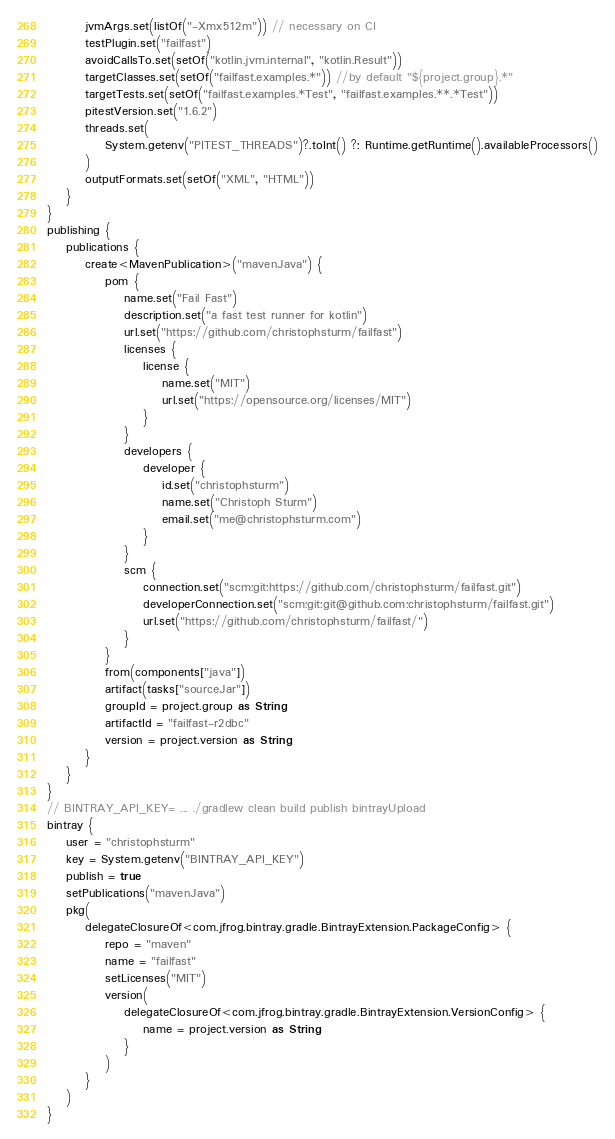<code> <loc_0><loc_0><loc_500><loc_500><_Kotlin_>        jvmArgs.set(listOf("-Xmx512m")) // necessary on CI
        testPlugin.set("failfast")
        avoidCallsTo.set(setOf("kotlin.jvm.internal", "kotlin.Result"))
        targetClasses.set(setOf("failfast.examples.*")) //by default "${project.group}.*"
        targetTests.set(setOf("failfast.examples.*Test", "failfast.examples.**.*Test"))
        pitestVersion.set("1.6.2")
        threads.set(
            System.getenv("PITEST_THREADS")?.toInt() ?: Runtime.getRuntime().availableProcessors()
        )
        outputFormats.set(setOf("XML", "HTML"))
    }
}
publishing {
    publications {
        create<MavenPublication>("mavenJava") {
            pom {
                name.set("Fail Fast")
                description.set("a fast test runner for kotlin")
                url.set("https://github.com/christophsturm/failfast")
                licenses {
                    license {
                        name.set("MIT")
                        url.set("https://opensource.org/licenses/MIT")
                    }
                }
                developers {
                    developer {
                        id.set("christophsturm")
                        name.set("Christoph Sturm")
                        email.set("me@christophsturm.com")
                    }
                }
                scm {
                    connection.set("scm:git:https://github.com/christophsturm/failfast.git")
                    developerConnection.set("scm:git:git@github.com:christophsturm/failfast.git")
                    url.set("https://github.com/christophsturm/failfast/")
                }
            }
            from(components["java"])
            artifact(tasks["sourceJar"])
            groupId = project.group as String
            artifactId = "failfast-r2dbc"
            version = project.version as String
        }
    }
}
// BINTRAY_API_KEY= ... ./gradlew clean build publish bintrayUpload
bintray {
    user = "christophsturm"
    key = System.getenv("BINTRAY_API_KEY")
    publish = true
    setPublications("mavenJava")
    pkg(
        delegateClosureOf<com.jfrog.bintray.gradle.BintrayExtension.PackageConfig> {
            repo = "maven"
            name = "failfast"
            setLicenses("MIT")
            version(
                delegateClosureOf<com.jfrog.bintray.gradle.BintrayExtension.VersionConfig> {
                    name = project.version as String
                }
            )
        }
    )
}


</code> 